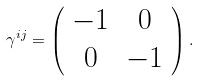Convert formula to latex. <formula><loc_0><loc_0><loc_500><loc_500>\gamma ^ { i j } = \left ( \begin{array} { c c } - 1 & 0 \\ 0 & - 1 \end{array} \right ) .</formula> 